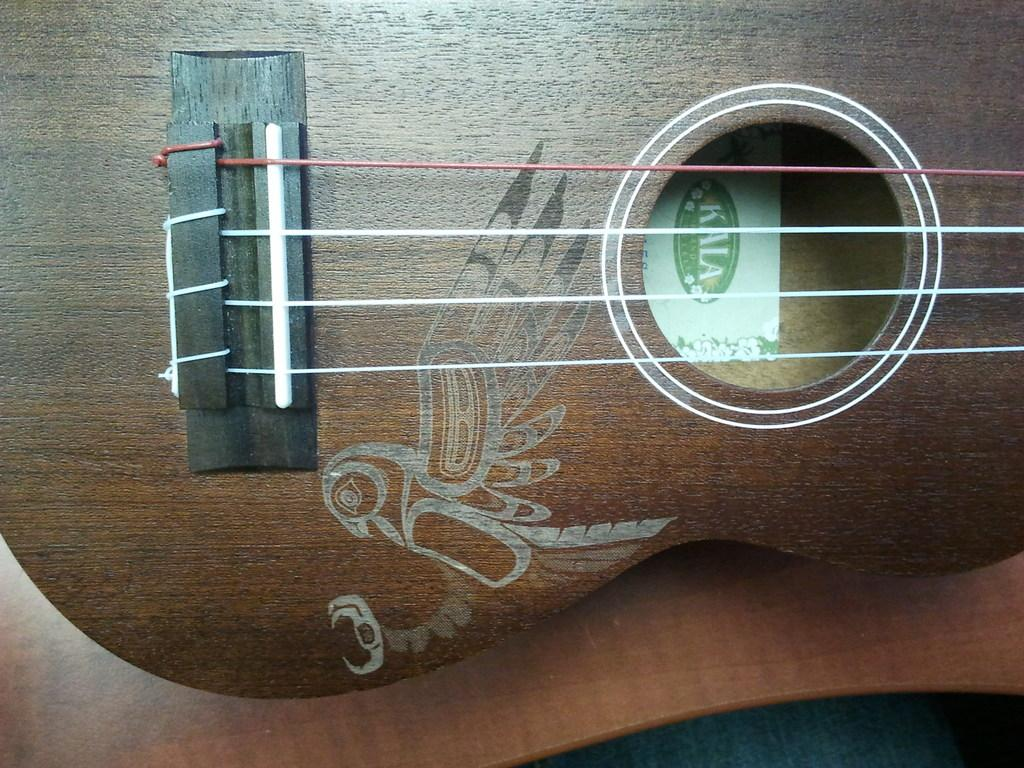What musical instrument is present in the image? There is a guitar in the image. How many strings does the guitar have? The guitar has four strings. What type of scent can be smelled coming from the guitar in the image? There is no scent associated with the guitar in the image, as it is a visual representation and does not emit any smell. 